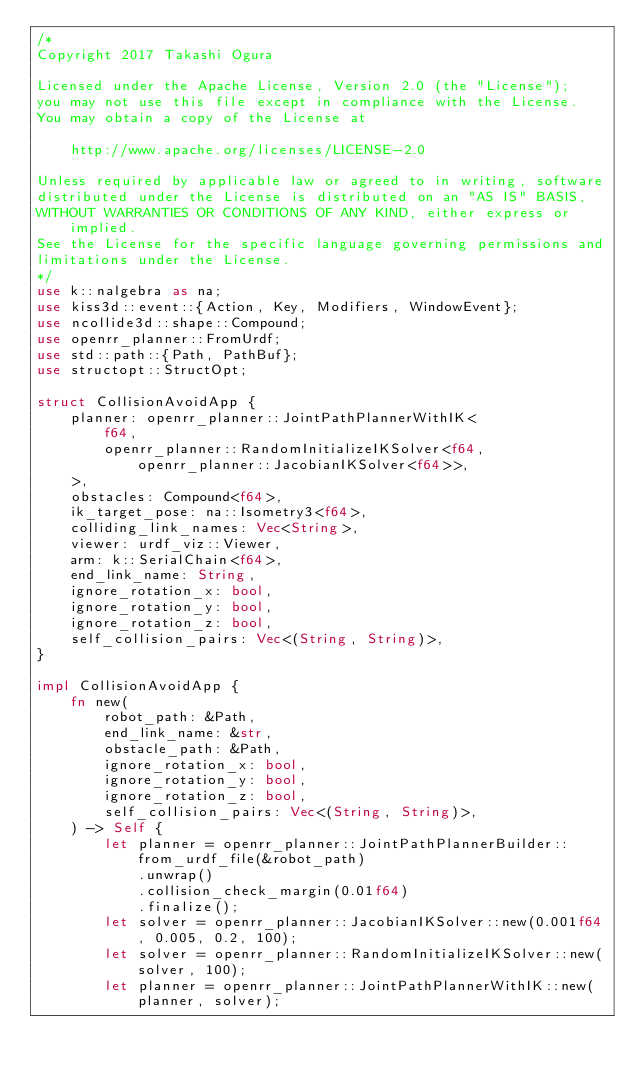Convert code to text. <code><loc_0><loc_0><loc_500><loc_500><_Rust_>/*
Copyright 2017 Takashi Ogura

Licensed under the Apache License, Version 2.0 (the "License");
you may not use this file except in compliance with the License.
You may obtain a copy of the License at

    http://www.apache.org/licenses/LICENSE-2.0

Unless required by applicable law or agreed to in writing, software
distributed under the License is distributed on an "AS IS" BASIS,
WITHOUT WARRANTIES OR CONDITIONS OF ANY KIND, either express or implied.
See the License for the specific language governing permissions and
limitations under the License.
*/
use k::nalgebra as na;
use kiss3d::event::{Action, Key, Modifiers, WindowEvent};
use ncollide3d::shape::Compound;
use openrr_planner::FromUrdf;
use std::path::{Path, PathBuf};
use structopt::StructOpt;

struct CollisionAvoidApp {
    planner: openrr_planner::JointPathPlannerWithIK<
        f64,
        openrr_planner::RandomInitializeIKSolver<f64, openrr_planner::JacobianIKSolver<f64>>,
    >,
    obstacles: Compound<f64>,
    ik_target_pose: na::Isometry3<f64>,
    colliding_link_names: Vec<String>,
    viewer: urdf_viz::Viewer,
    arm: k::SerialChain<f64>,
    end_link_name: String,
    ignore_rotation_x: bool,
    ignore_rotation_y: bool,
    ignore_rotation_z: bool,
    self_collision_pairs: Vec<(String, String)>,
}

impl CollisionAvoidApp {
    fn new(
        robot_path: &Path,
        end_link_name: &str,
        obstacle_path: &Path,
        ignore_rotation_x: bool,
        ignore_rotation_y: bool,
        ignore_rotation_z: bool,
        self_collision_pairs: Vec<(String, String)>,
    ) -> Self {
        let planner = openrr_planner::JointPathPlannerBuilder::from_urdf_file(&robot_path)
            .unwrap()
            .collision_check_margin(0.01f64)
            .finalize();
        let solver = openrr_planner::JacobianIKSolver::new(0.001f64, 0.005, 0.2, 100);
        let solver = openrr_planner::RandomInitializeIKSolver::new(solver, 100);
        let planner = openrr_planner::JointPathPlannerWithIK::new(planner, solver);</code> 